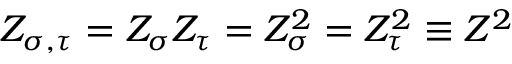Convert formula to latex. <formula><loc_0><loc_0><loc_500><loc_500>Z _ { \sigma , \tau } = Z _ { \sigma } Z _ { \tau } = Z _ { \sigma } ^ { 2 } = Z _ { \tau } ^ { 2 } \equiv Z ^ { 2 }</formula> 